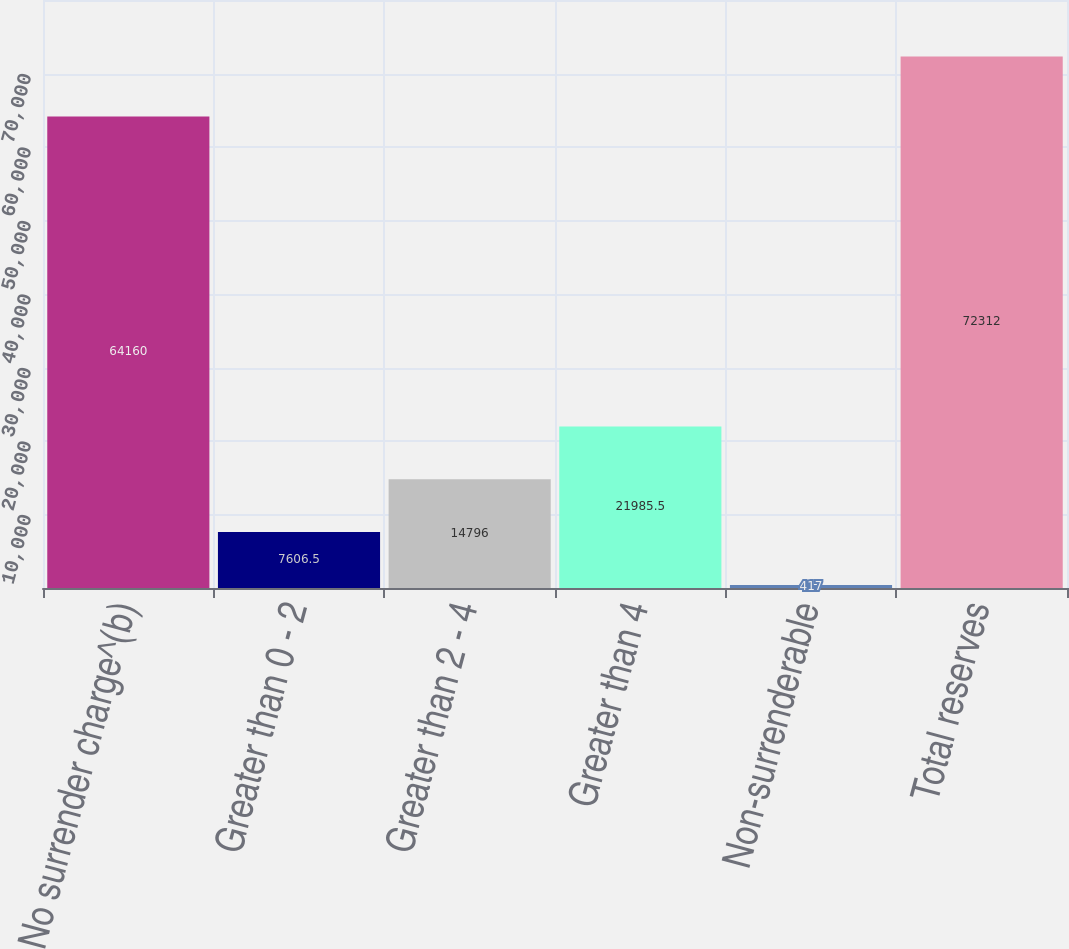<chart> <loc_0><loc_0><loc_500><loc_500><bar_chart><fcel>No surrender charge^(b)<fcel>Greater than 0 - 2<fcel>Greater than 2 - 4<fcel>Greater than 4<fcel>Non-surrenderable<fcel>Total reserves<nl><fcel>64160<fcel>7606.5<fcel>14796<fcel>21985.5<fcel>417<fcel>72312<nl></chart> 